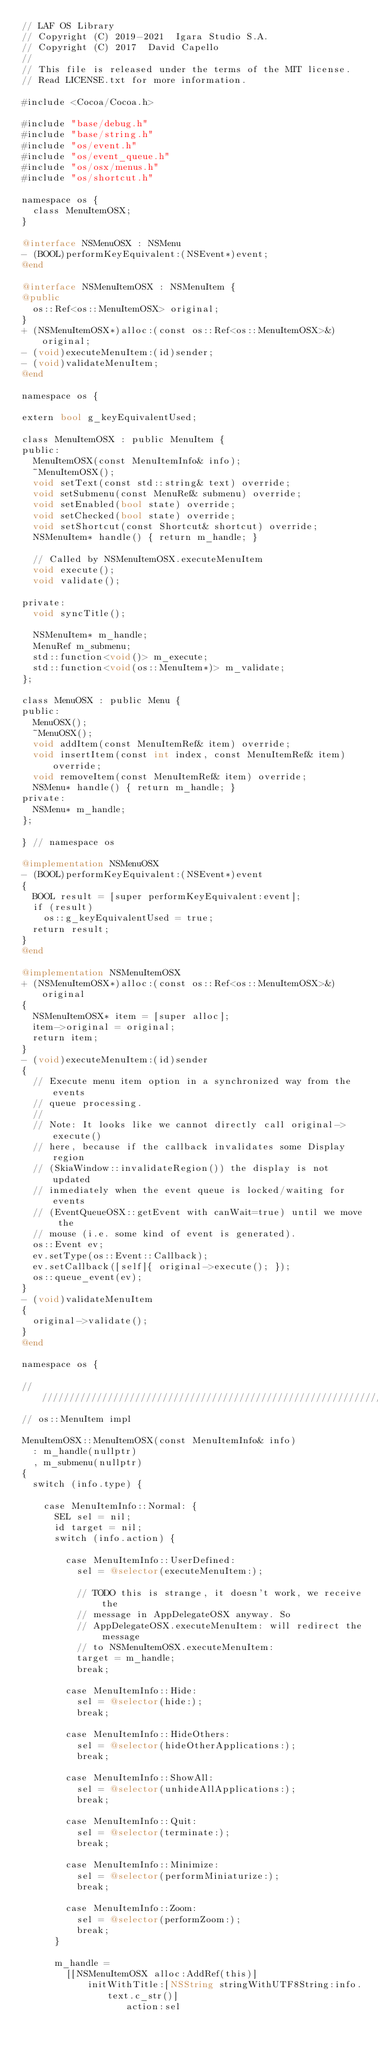<code> <loc_0><loc_0><loc_500><loc_500><_ObjectiveC_>// LAF OS Library
// Copyright (C) 2019-2021  Igara Studio S.A.
// Copyright (C) 2017  David Capello
//
// This file is released under the terms of the MIT license.
// Read LICENSE.txt for more information.

#include <Cocoa/Cocoa.h>

#include "base/debug.h"
#include "base/string.h"
#include "os/event.h"
#include "os/event_queue.h"
#include "os/osx/menus.h"
#include "os/shortcut.h"

namespace os {
  class MenuItemOSX;
}

@interface NSMenuOSX : NSMenu
- (BOOL)performKeyEquivalent:(NSEvent*)event;
@end

@interface NSMenuItemOSX : NSMenuItem {
@public
  os::Ref<os::MenuItemOSX> original;
}
+ (NSMenuItemOSX*)alloc:(const os::Ref<os::MenuItemOSX>&)original;
- (void)executeMenuItem:(id)sender;
- (void)validateMenuItem;
@end

namespace os {

extern bool g_keyEquivalentUsed;

class MenuItemOSX : public MenuItem {
public:
  MenuItemOSX(const MenuItemInfo& info);
  ~MenuItemOSX();
  void setText(const std::string& text) override;
  void setSubmenu(const MenuRef& submenu) override;
  void setEnabled(bool state) override;
  void setChecked(bool state) override;
  void setShortcut(const Shortcut& shortcut) override;
  NSMenuItem* handle() { return m_handle; }

  // Called by NSMenuItemOSX.executeMenuItem
  void execute();
  void validate();

private:
  void syncTitle();

  NSMenuItem* m_handle;
  MenuRef m_submenu;
  std::function<void()> m_execute;
  std::function<void(os::MenuItem*)> m_validate;
};

class MenuOSX : public Menu {
public:
  MenuOSX();
  ~MenuOSX();
  void addItem(const MenuItemRef& item) override;
  void insertItem(const int index, const MenuItemRef& item) override;
  void removeItem(const MenuItemRef& item) override;
  NSMenu* handle() { return m_handle; }
private:
  NSMenu* m_handle;
};

} // namespace os

@implementation NSMenuOSX
- (BOOL)performKeyEquivalent:(NSEvent*)event
{
  BOOL result = [super performKeyEquivalent:event];
  if (result)
    os::g_keyEquivalentUsed = true;
  return result;
}
@end

@implementation NSMenuItemOSX
+ (NSMenuItemOSX*)alloc:(const os::Ref<os::MenuItemOSX>&)original
{
  NSMenuItemOSX* item = [super alloc];
  item->original = original;
  return item;
}
- (void)executeMenuItem:(id)sender
{
  // Execute menu item option in a synchronized way from the events
  // queue processing.
  //
  // Note: It looks like we cannot directly call original->execute()
  // here, because if the callback invalidates some Display region
  // (SkiaWindow::invalidateRegion()) the display is not updated
  // inmediately when the event queue is locked/waiting for events
  // (EventQueueOSX::getEvent with canWait=true) until we move the
  // mouse (i.e. some kind of event is generated).
  os::Event ev;
  ev.setType(os::Event::Callback);
  ev.setCallback([self]{ original->execute(); });
  os::queue_event(ev);
}
- (void)validateMenuItem
{
  original->validate();
}
@end

namespace os {

//////////////////////////////////////////////////////////////////////
// os::MenuItem impl

MenuItemOSX::MenuItemOSX(const MenuItemInfo& info)
  : m_handle(nullptr)
  , m_submenu(nullptr)
{
  switch (info.type) {

    case MenuItemInfo::Normal: {
      SEL sel = nil;
      id target = nil;
      switch (info.action) {

        case MenuItemInfo::UserDefined:
          sel = @selector(executeMenuItem:);

          // TODO this is strange, it doesn't work, we receive the
          // message in AppDelegateOSX anyway. So
          // AppDelegateOSX.executeMenuItem: will redirect the message
          // to NSMenuItemOSX.executeMenuItem:
          target = m_handle;
          break;

        case MenuItemInfo::Hide:
          sel = @selector(hide:);
          break;

        case MenuItemInfo::HideOthers:
          sel = @selector(hideOtherApplications:);
          break;

        case MenuItemInfo::ShowAll:
          sel = @selector(unhideAllApplications:);
          break;

        case MenuItemInfo::Quit:
          sel = @selector(terminate:);
          break;

        case MenuItemInfo::Minimize:
          sel = @selector(performMiniaturize:);
          break;

        case MenuItemInfo::Zoom:
          sel = @selector(performZoom:);
          break;
      }

      m_handle =
        [[NSMenuItemOSX alloc:AddRef(this)]
            initWithTitle:[NSString stringWithUTF8String:info.text.c_str()]
                   action:sel</code> 